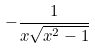<formula> <loc_0><loc_0><loc_500><loc_500>- \frac { 1 } { x \sqrt { x ^ { 2 } - 1 } }</formula> 